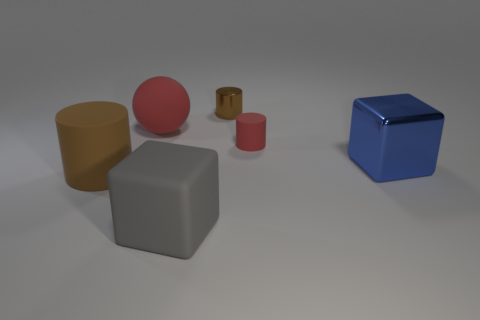Add 2 shiny blocks. How many objects exist? 8 Subtract all cyan cubes. Subtract all green cylinders. How many cubes are left? 2 Subtract all blocks. How many objects are left? 4 Add 5 tiny red cylinders. How many tiny red cylinders are left? 6 Add 6 large metallic blocks. How many large metallic blocks exist? 7 Subtract 0 blue cylinders. How many objects are left? 6 Subtract all large blue metallic cubes. Subtract all small shiny objects. How many objects are left? 4 